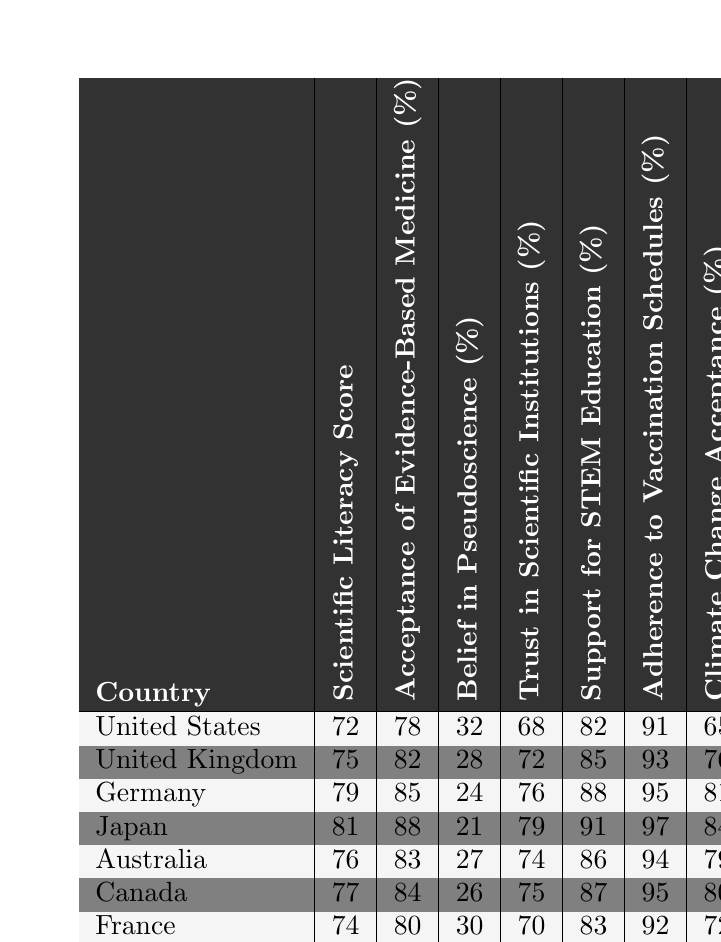What is the Scientific Literacy Score for Japan? The table shows the Scientific Literacy Score for Japan as 81.
Answer: 81 What percentage of the population in Germany accepts Evidence-Based Medicine? According to the table, Germany has an Acceptance of Evidence-Based Medicine percentage of 85%.
Answer: 85% Which country has the highest Trust in Scientific Institutions (%)? By comparing the Trust in Scientific Institutions percentages, Japan has the highest score at 79%.
Answer: Japan What is the difference in Adherence to Vaccination Schedules (%) between the United States and Canada? The Adherence to Vaccination Schedules for the United States is 91%, while for Canada it is 95%. The difference is 95 - 91 = 4%.
Answer: 4% What is the average Scientific Literacy Score of the countries listed? The scores for each country are 72, 75, 79, 81, 76, 77, 74, and 82. The total sum is 72 + 75 + 79 + 81 + 76 + 77 + 74 + 82 = 615. There are 8 countries, so the average is 615 / 8 = 76.875.
Answer: 76.875 Is the belief in pseudoscience higher in the United States than in Canada? The table indicates that the Belief in Pseudoscience in the United States is 32%, while in Canada it is 26%. Since 32% is greater than 26%, the statement is true.
Answer: Yes Which country has both the highest Acceptance of Evidence-Based Medicine and the lowest Belief in Pseudoscience? Japan has the highest Acceptance of Evidence-Based Medicine at 88% and the lowest Belief in Pseudoscience at 21%.
Answer: Japan If Sweden had a Scientific Literacy Score of 80 instead of 82, how would that affect its comparison with Germany? Sweden would have a lower Scientific Literacy Score compared to Germany (79). Since both have high literacy scores, the overall impression of Sweden's literacy would be diminished in relation to Germany’s, but the Acceptance of Evidence-Based Medicine would still be higher in Sweden at 89%.
Answer: Sweden would be lower in Literacy but higher in Acceptance 